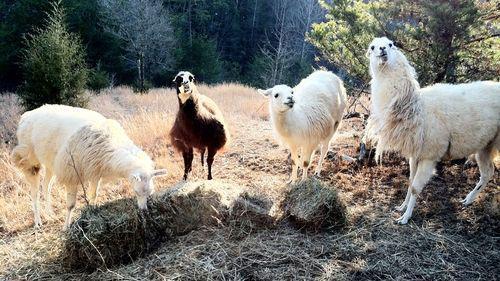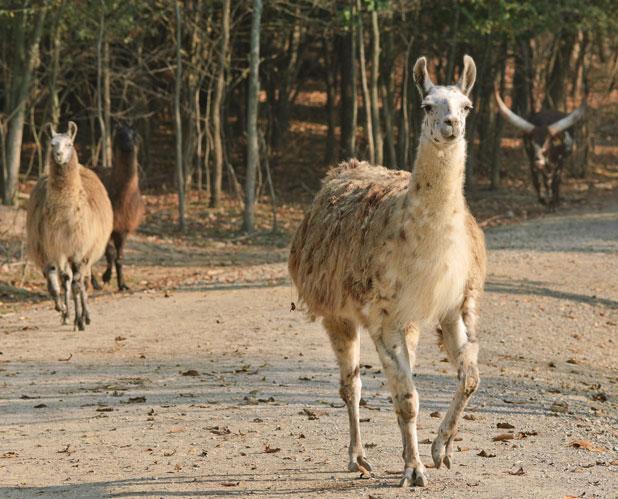The first image is the image on the left, the second image is the image on the right. Given the left and right images, does the statement "An image contains two llamas standing in front of a fence and near at least one white animal that is not a llama." hold true? Answer yes or no. No. The first image is the image on the left, the second image is the image on the right. Analyze the images presented: Is the assertion "There is a single llama in one image." valid? Answer yes or no. No. 